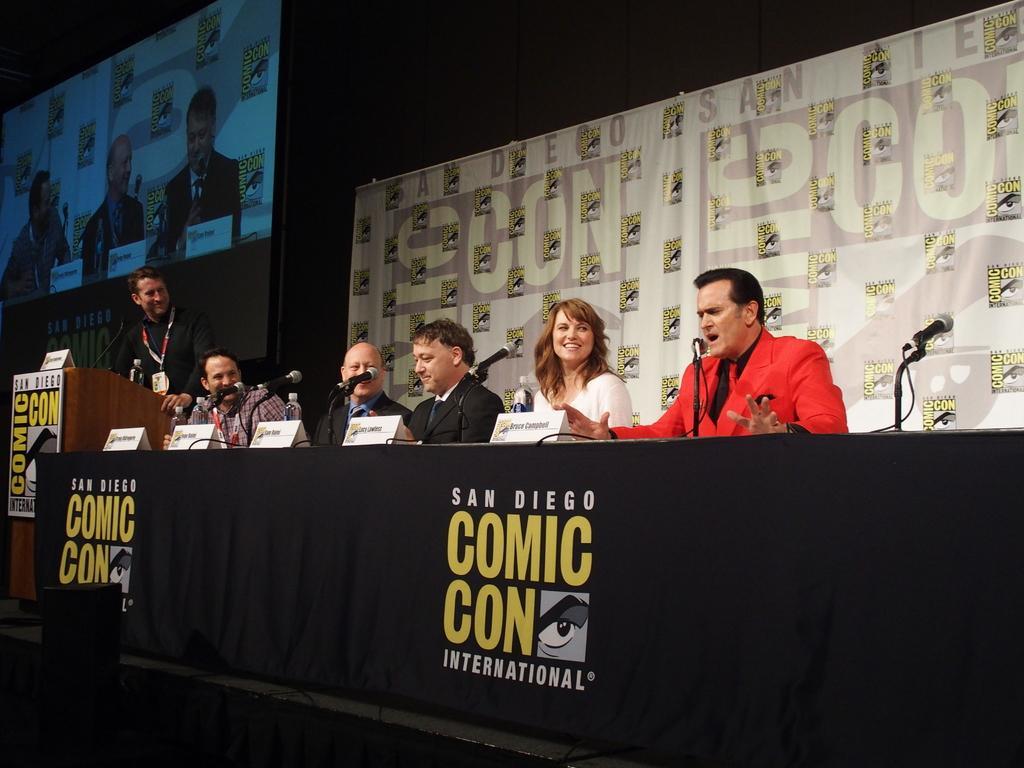Could you give a brief overview of what you see in this image? In this image, there are five persons sitting and a person standing. There are mike's, name boards and water bottles on a table, which is covered with a cloth. On the left side of the image, I can see a podium with the boards and a mike. Behind the people, I can see a projector screen and a banner. There is a dark background. At the bottom left corner of the image, I can see an object. 